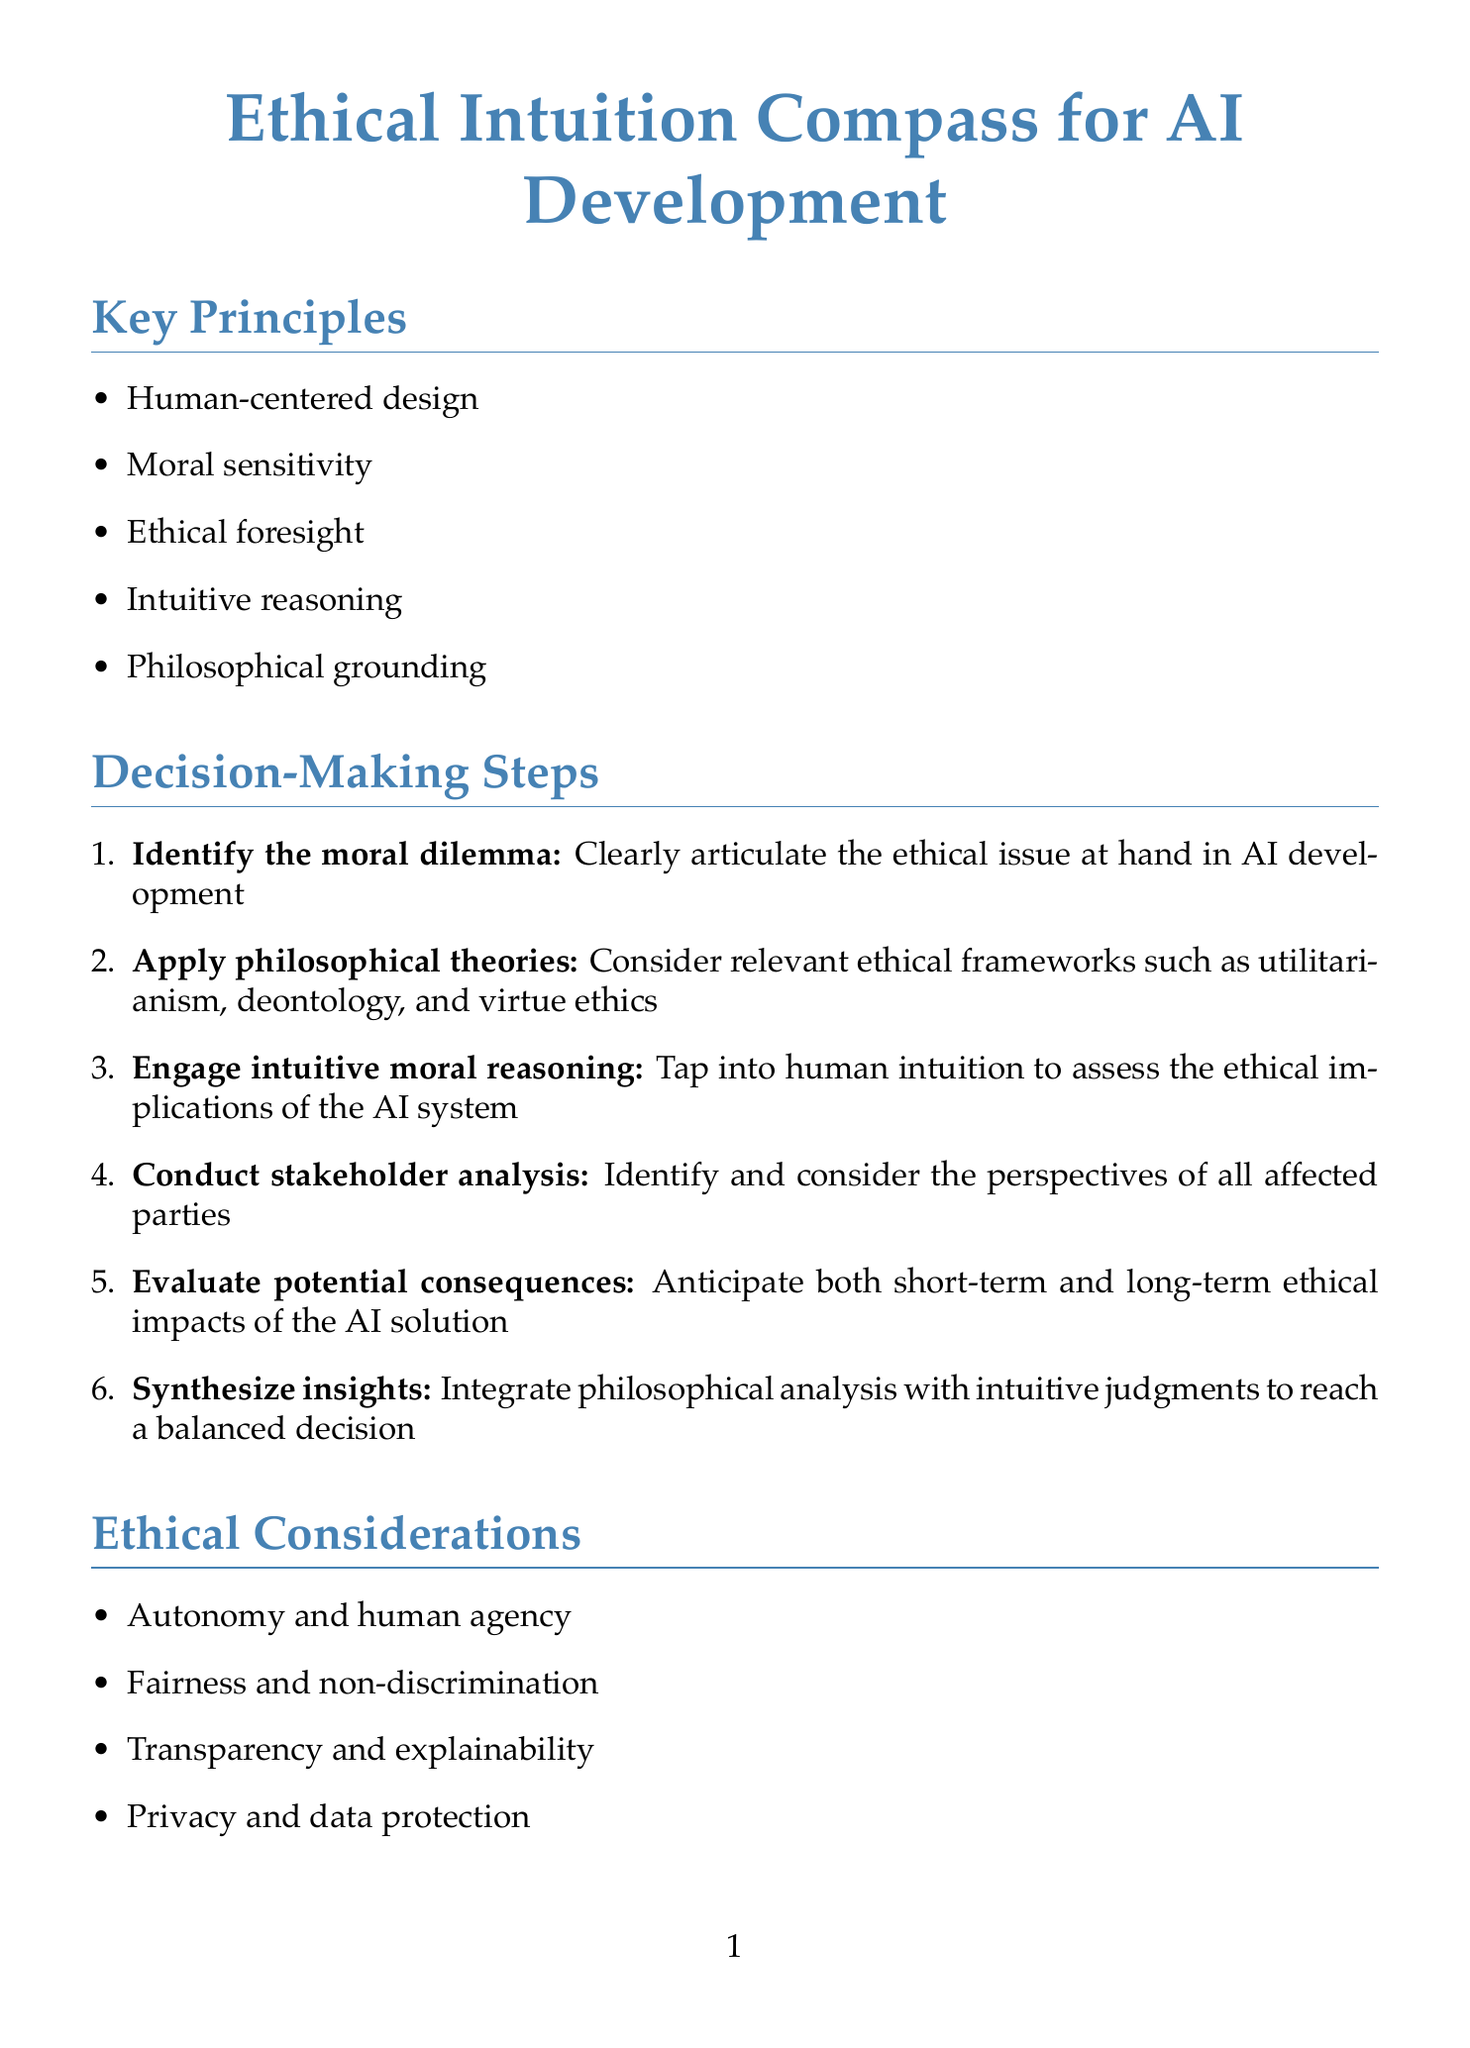What is the framework name? The framework name is prominently stated at the beginning of the document.
Answer: Ethical Intuition Compass for AI Development How many key principles are listed in the document? The total number of key principles is presented in the Key Principles section.
Answer: Five What is the first step in the decision-making process? The first step is outlined in the Decision-Making Steps section of the document.
Answer: Identify the moral dilemma Who authored "Human Compatible: Artificial Intelligence and the Problem of Control"? The author of this philosophical resource can be found in the Philosophical Resources section.
Answer: Stuart Russell What ethical consideration involves human agency? Ethical considerations are listed, and one specifically addresses human agency.
Answer: Autonomy and human agency What technique is suggested for enhancing intuition? Techniques to enhance intuition are specified in the Intuition Enhancement Techniques section.
Answer: Ethical scenario visualization What are the evaluation criteria for the framework? The criteria for evaluating the framework are clearly listed in the Framework Evaluation Criteria section.
Answer: Ethical robustness, intuitive accessibility, philosophical coherence, practical applicability, adaptability to emerging technologies Who is an expert in Robot Ethics? The Expert Panel section lists individuals and their areas of expertise.
Answer: Dr. Kate Darling 